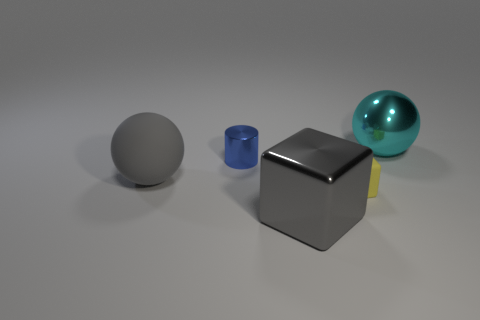How many blue things are small metallic cylinders or big rubber things?
Keep it short and to the point. 1. What material is the cylinder behind the gray object that is right of the cylinder?
Provide a succinct answer. Metal. Is the shape of the cyan metallic object the same as the gray rubber object?
Give a very brief answer. Yes. The matte block that is the same size as the blue thing is what color?
Provide a succinct answer. Yellow. Are there any things that have the same color as the matte ball?
Provide a short and direct response. Yes. Are any red things visible?
Make the answer very short. No. Are the large sphere that is on the right side of the big gray matte object and the small yellow thing made of the same material?
Your answer should be very brief. No. What is the size of the other thing that is the same color as the big rubber thing?
Keep it short and to the point. Large. What number of gray things have the same size as the rubber ball?
Your answer should be compact. 1. Are there an equal number of large things on the left side of the gray cube and blue shiny objects?
Give a very brief answer. Yes. 